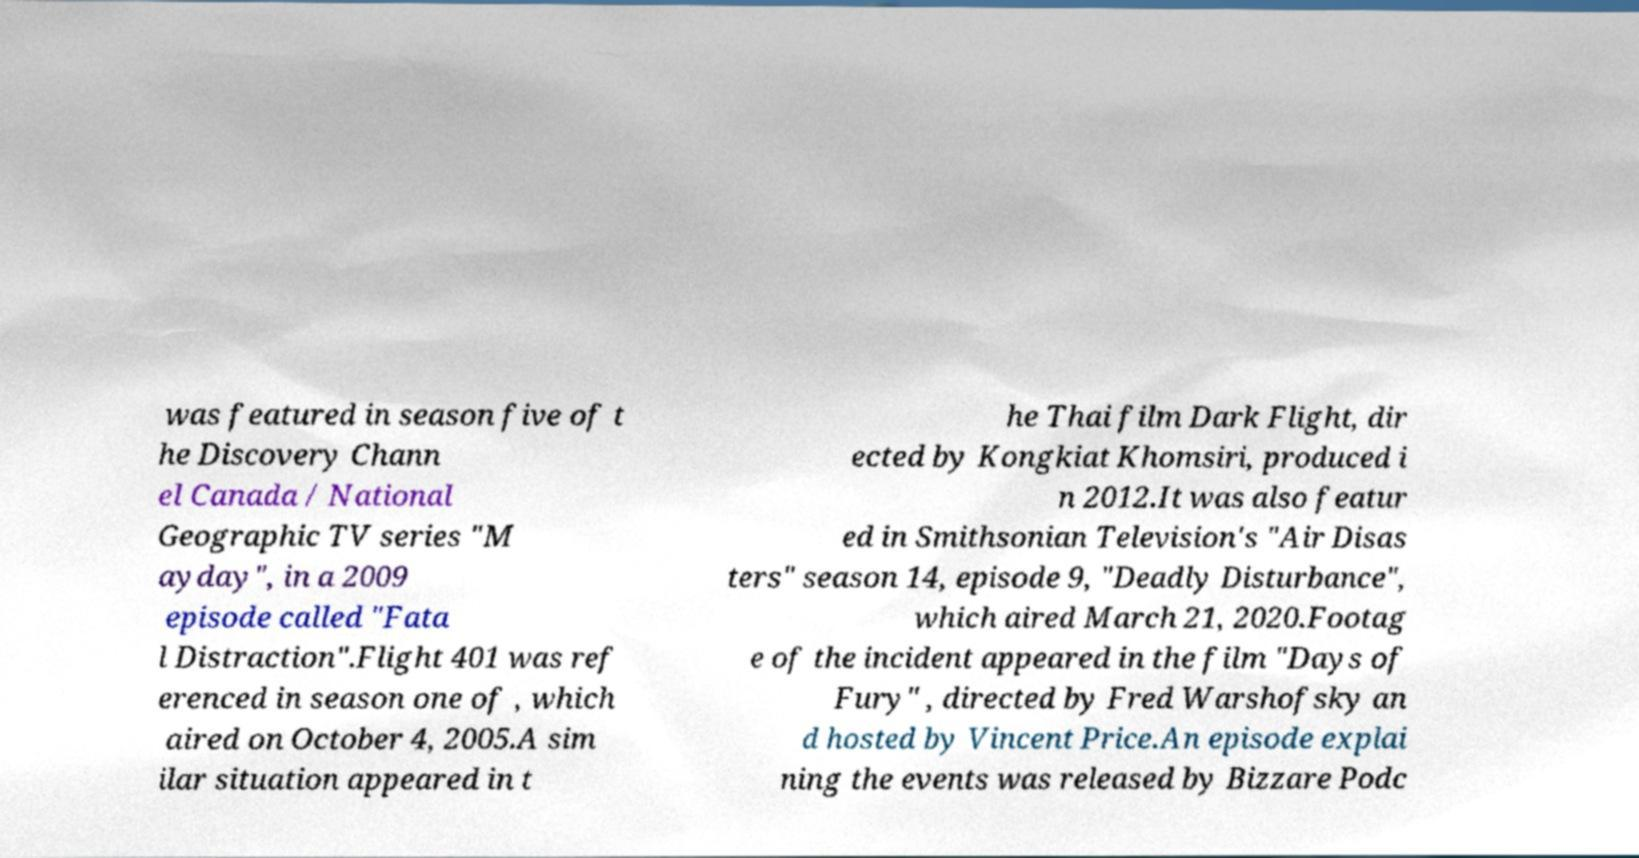There's text embedded in this image that I need extracted. Can you transcribe it verbatim? was featured in season five of t he Discovery Chann el Canada / National Geographic TV series "M ayday", in a 2009 episode called "Fata l Distraction".Flight 401 was ref erenced in season one of , which aired on October 4, 2005.A sim ilar situation appeared in t he Thai film Dark Flight, dir ected by Kongkiat Khomsiri, produced i n 2012.It was also featur ed in Smithsonian Television's "Air Disas ters" season 14, episode 9, "Deadly Disturbance", which aired March 21, 2020.Footag e of the incident appeared in the film "Days of Fury" , directed by Fred Warshofsky an d hosted by Vincent Price.An episode explai ning the events was released by Bizzare Podc 